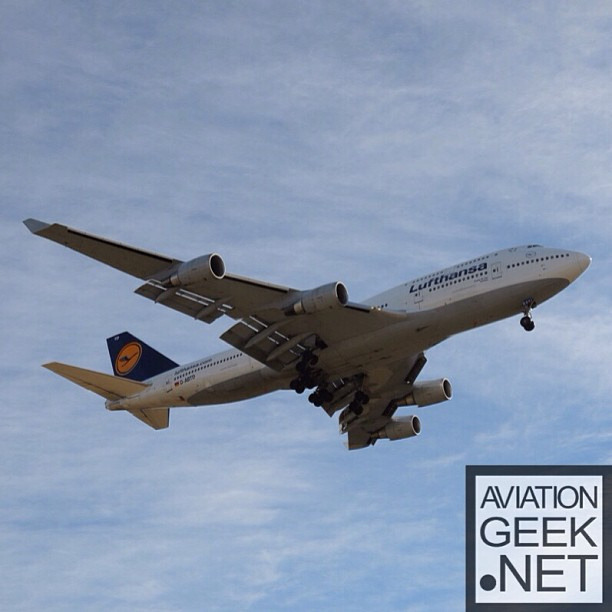Please transcribe the text in this image. AVIATION GEEK NET 